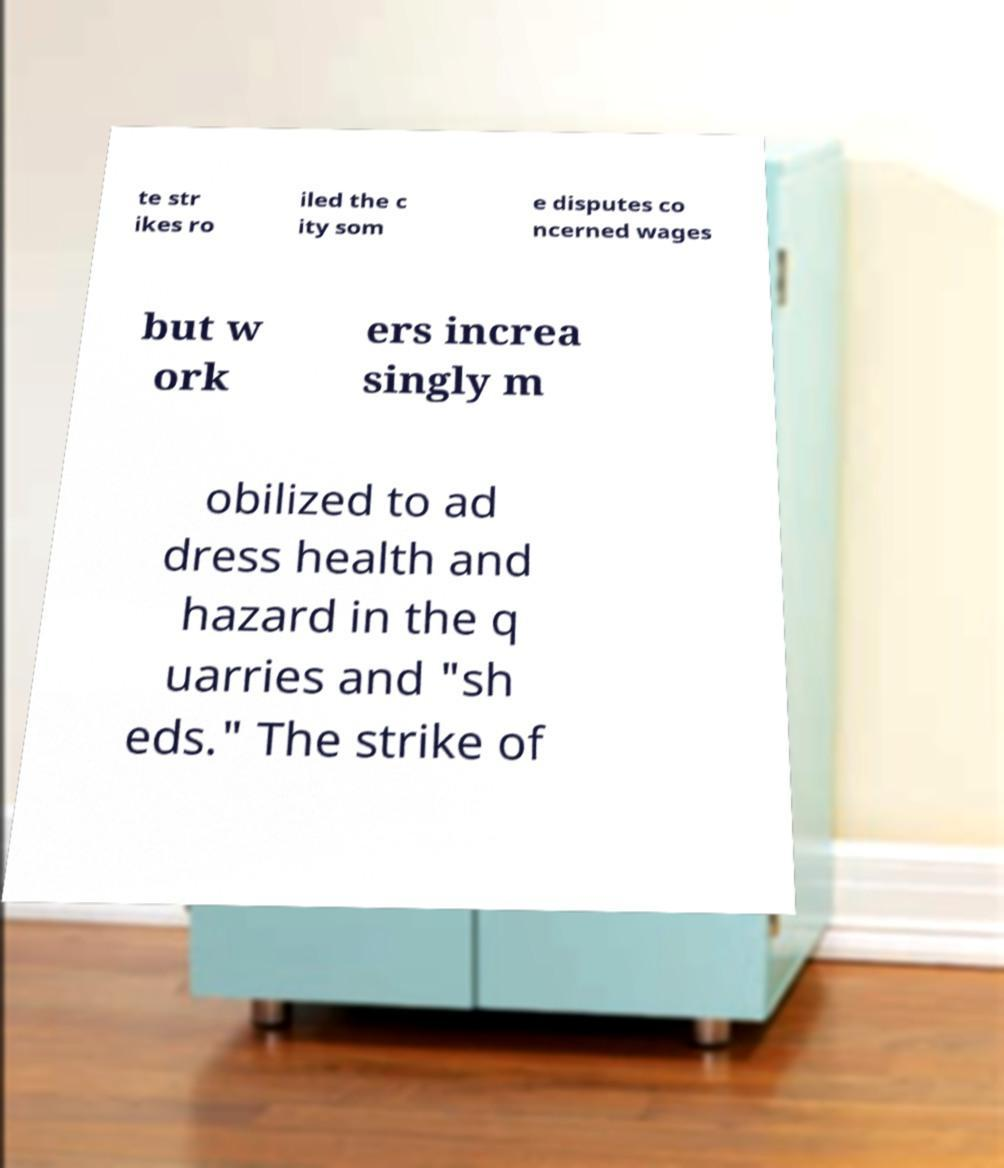Can you accurately transcribe the text from the provided image for me? te str ikes ro iled the c ity som e disputes co ncerned wages but w ork ers increa singly m obilized to ad dress health and hazard in the q uarries and "sh eds." The strike of 